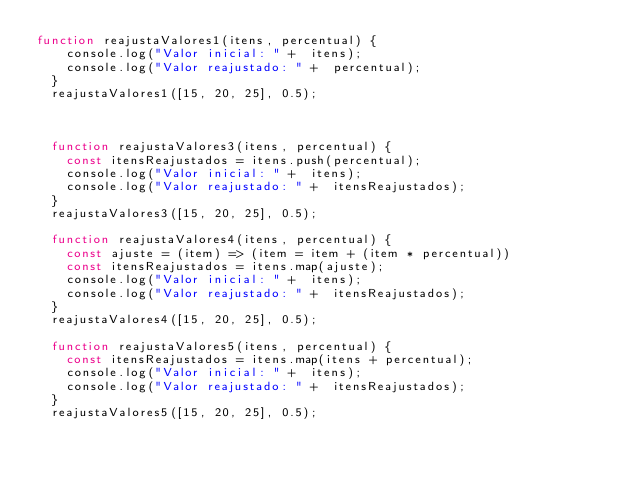<code> <loc_0><loc_0><loc_500><loc_500><_JavaScript_>function reajustaValores1(itens, percentual) {
    console.log("Valor inicial: " +  itens);
    console.log("Valor reajustado: " +  percentual);
  }
  reajustaValores1([15, 20, 25], 0.5);

  

  function reajustaValores3(itens, percentual) {
    const itensReajustados = itens.push(percentual);
    console.log("Valor inicial: " +  itens);
    console.log("Valor reajustado: " +  itensReajustados);
  }
  reajustaValores3([15, 20, 25], 0.5);

  function reajustaValores4(itens, percentual) {
    const ajuste = (item) => (item = item + (item * percentual))
    const itensReajustados = itens.map(ajuste);
    console.log("Valor inicial: " +  itens);
    console.log("Valor reajustado: " +  itensReajustados);
  }
  reajustaValores4([15, 20, 25], 0.5);

  function reajustaValores5(itens, percentual) {
    const itensReajustados = itens.map(itens + percentual);
    console.log("Valor inicial: " +  itens);
    console.log("Valor reajustado: " +  itensReajustados);
  }
  reajustaValores5([15, 20, 25], 0.5);</code> 